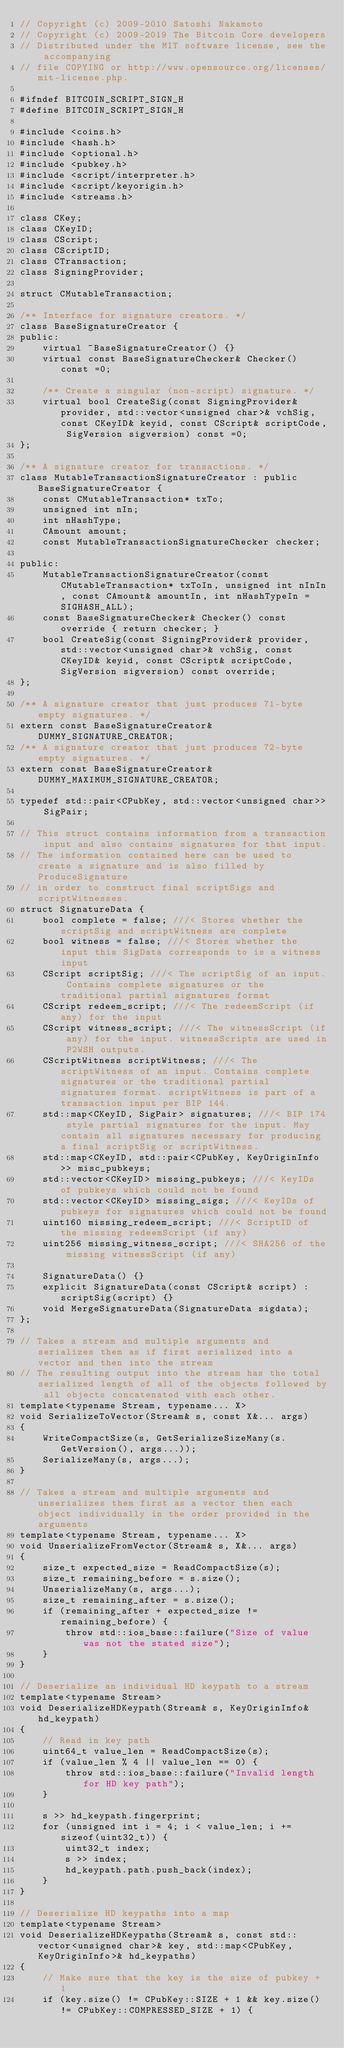<code> <loc_0><loc_0><loc_500><loc_500><_C_>// Copyright (c) 2009-2010 Satoshi Nakamoto
// Copyright (c) 2009-2019 The Bitcoin Core developers
// Distributed under the MIT software license, see the accompanying
// file COPYING or http://www.opensource.org/licenses/mit-license.php.

#ifndef BITCOIN_SCRIPT_SIGN_H
#define BITCOIN_SCRIPT_SIGN_H

#include <coins.h>
#include <hash.h>
#include <optional.h>
#include <pubkey.h>
#include <script/interpreter.h>
#include <script/keyorigin.h>
#include <streams.h>

class CKey;
class CKeyID;
class CScript;
class CScriptID;
class CTransaction;
class SigningProvider;

struct CMutableTransaction;

/** Interface for signature creators. */
class BaseSignatureCreator {
public:
    virtual ~BaseSignatureCreator() {}
    virtual const BaseSignatureChecker& Checker() const =0;

    /** Create a singular (non-script) signature. */
    virtual bool CreateSig(const SigningProvider& provider, std::vector<unsigned char>& vchSig, const CKeyID& keyid, const CScript& scriptCode, SigVersion sigversion) const =0;
};

/** A signature creator for transactions. */
class MutableTransactionSignatureCreator : public BaseSignatureCreator {
    const CMutableTransaction* txTo;
    unsigned int nIn;
    int nHashType;
    CAmount amount;
    const MutableTransactionSignatureChecker checker;

public:
    MutableTransactionSignatureCreator(const CMutableTransaction* txToIn, unsigned int nInIn, const CAmount& amountIn, int nHashTypeIn = SIGHASH_ALL);
    const BaseSignatureChecker& Checker() const override { return checker; }
    bool CreateSig(const SigningProvider& provider, std::vector<unsigned char>& vchSig, const CKeyID& keyid, const CScript& scriptCode, SigVersion sigversion) const override;
};

/** A signature creator that just produces 71-byte empty signatures. */
extern const BaseSignatureCreator& DUMMY_SIGNATURE_CREATOR;
/** A signature creator that just produces 72-byte empty signatures. */
extern const BaseSignatureCreator& DUMMY_MAXIMUM_SIGNATURE_CREATOR;

typedef std::pair<CPubKey, std::vector<unsigned char>> SigPair;

// This struct contains information from a transaction input and also contains signatures for that input.
// The information contained here can be used to create a signature and is also filled by ProduceSignature
// in order to construct final scriptSigs and scriptWitnesses.
struct SignatureData {
    bool complete = false; ///< Stores whether the scriptSig and scriptWitness are complete
    bool witness = false; ///< Stores whether the input this SigData corresponds to is a witness input
    CScript scriptSig; ///< The scriptSig of an input. Contains complete signatures or the traditional partial signatures format
    CScript redeem_script; ///< The redeemScript (if any) for the input
    CScript witness_script; ///< The witnessScript (if any) for the input. witnessScripts are used in P2WSH outputs.
    CScriptWitness scriptWitness; ///< The scriptWitness of an input. Contains complete signatures or the traditional partial signatures format. scriptWitness is part of a transaction input per BIP 144.
    std::map<CKeyID, SigPair> signatures; ///< BIP 174 style partial signatures for the input. May contain all signatures necessary for producing a final scriptSig or scriptWitness.
    std::map<CKeyID, std::pair<CPubKey, KeyOriginInfo>> misc_pubkeys;
    std::vector<CKeyID> missing_pubkeys; ///< KeyIDs of pubkeys which could not be found
    std::vector<CKeyID> missing_sigs; ///< KeyIDs of pubkeys for signatures which could not be found
    uint160 missing_redeem_script; ///< ScriptID of the missing redeemScript (if any)
    uint256 missing_witness_script; ///< SHA256 of the missing witnessScript (if any)

    SignatureData() {}
    explicit SignatureData(const CScript& script) : scriptSig(script) {}
    void MergeSignatureData(SignatureData sigdata);
};

// Takes a stream and multiple arguments and serializes them as if first serialized into a vector and then into the stream
// The resulting output into the stream has the total serialized length of all of the objects followed by all objects concatenated with each other.
template<typename Stream, typename... X>
void SerializeToVector(Stream& s, const X&... args)
{
    WriteCompactSize(s, GetSerializeSizeMany(s.GetVersion(), args...));
    SerializeMany(s, args...);
}

// Takes a stream and multiple arguments and unserializes them first as a vector then each object individually in the order provided in the arguments
template<typename Stream, typename... X>
void UnserializeFromVector(Stream& s, X&... args)
{
    size_t expected_size = ReadCompactSize(s);
    size_t remaining_before = s.size();
    UnserializeMany(s, args...);
    size_t remaining_after = s.size();
    if (remaining_after + expected_size != remaining_before) {
        throw std::ios_base::failure("Size of value was not the stated size");
    }
}

// Deserialize an individual HD keypath to a stream
template<typename Stream>
void DeserializeHDKeypath(Stream& s, KeyOriginInfo& hd_keypath)
{
    // Read in key path
    uint64_t value_len = ReadCompactSize(s);
    if (value_len % 4 || value_len == 0) {
        throw std::ios_base::failure("Invalid length for HD key path");
    }

    s >> hd_keypath.fingerprint;
    for (unsigned int i = 4; i < value_len; i += sizeof(uint32_t)) {
        uint32_t index;
        s >> index;
        hd_keypath.path.push_back(index);
    }
}

// Deserialize HD keypaths into a map
template<typename Stream>
void DeserializeHDKeypaths(Stream& s, const std::vector<unsigned char>& key, std::map<CPubKey, KeyOriginInfo>& hd_keypaths)
{
    // Make sure that the key is the size of pubkey + 1
    if (key.size() != CPubKey::SIZE + 1 && key.size() != CPubKey::COMPRESSED_SIZE + 1) {</code> 